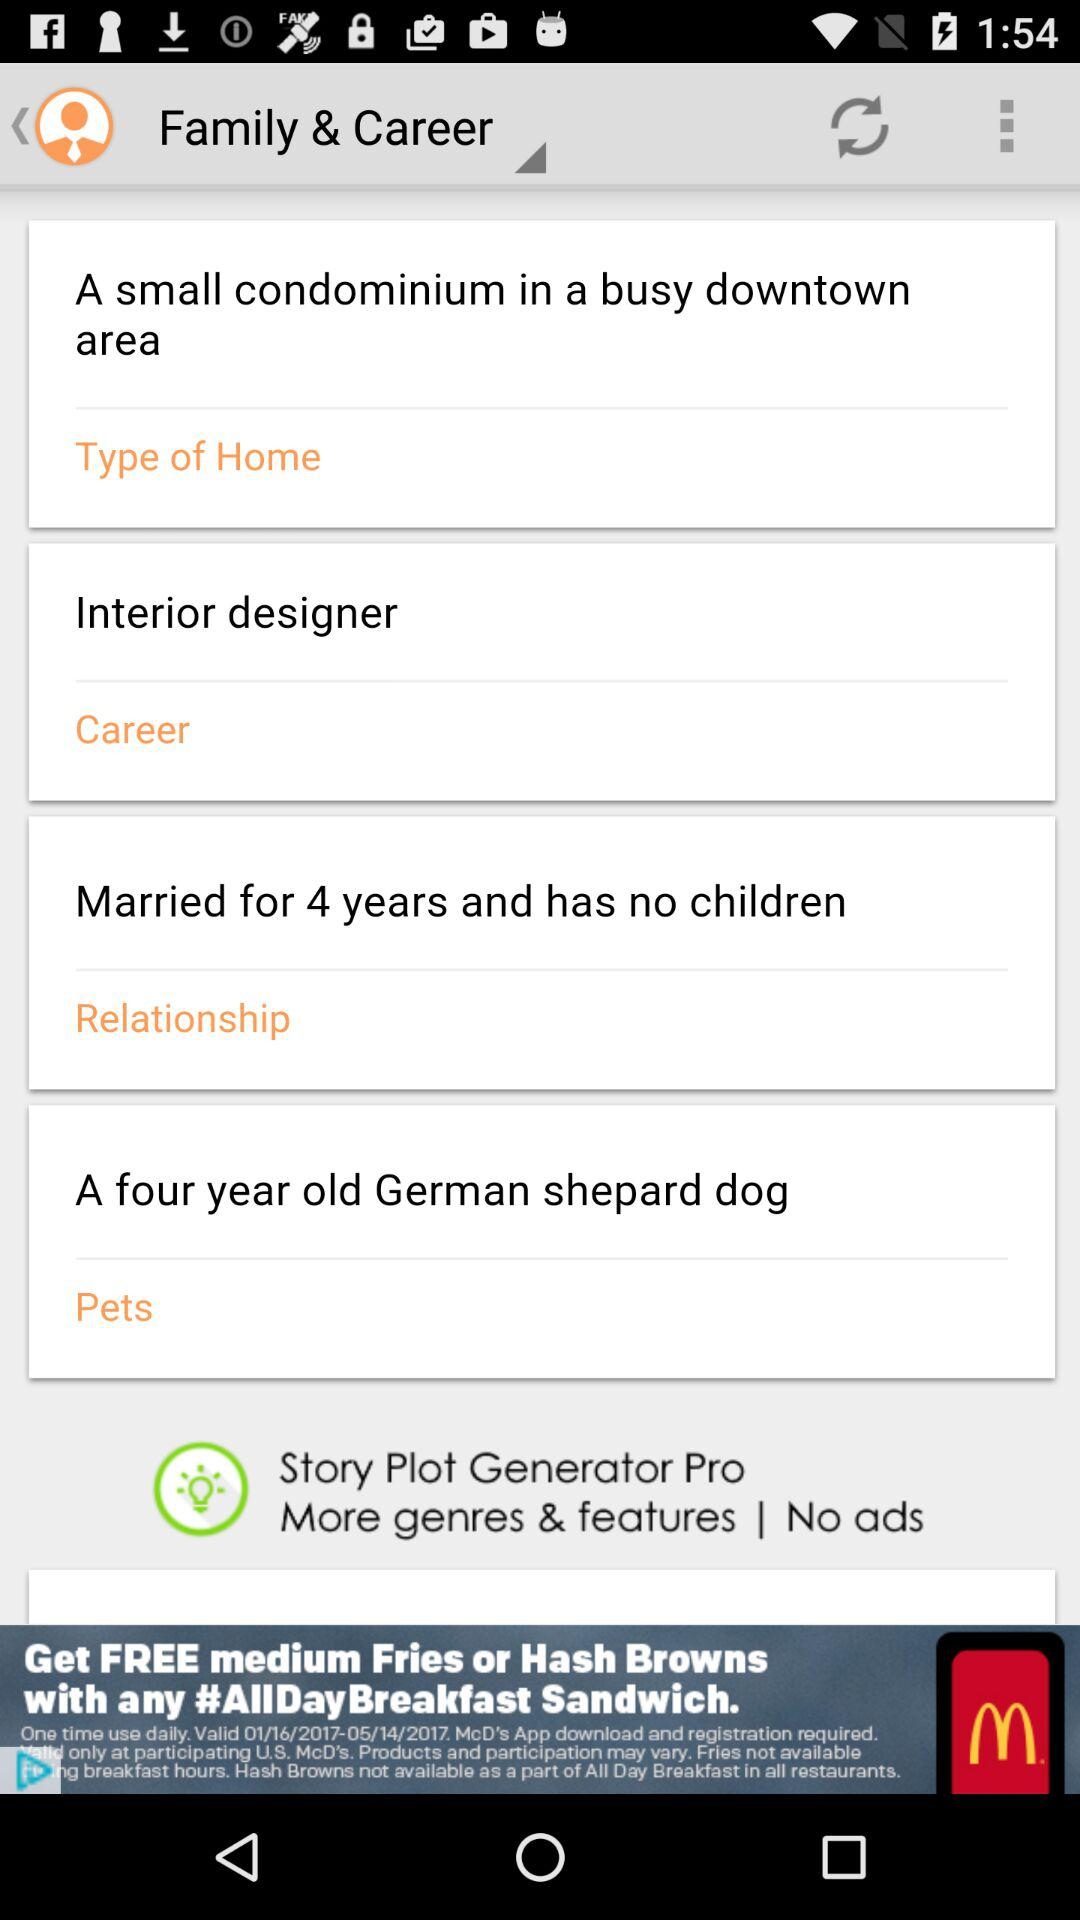What is the age of the German shepherd dog? The age of the German shepherd dog is four years. 